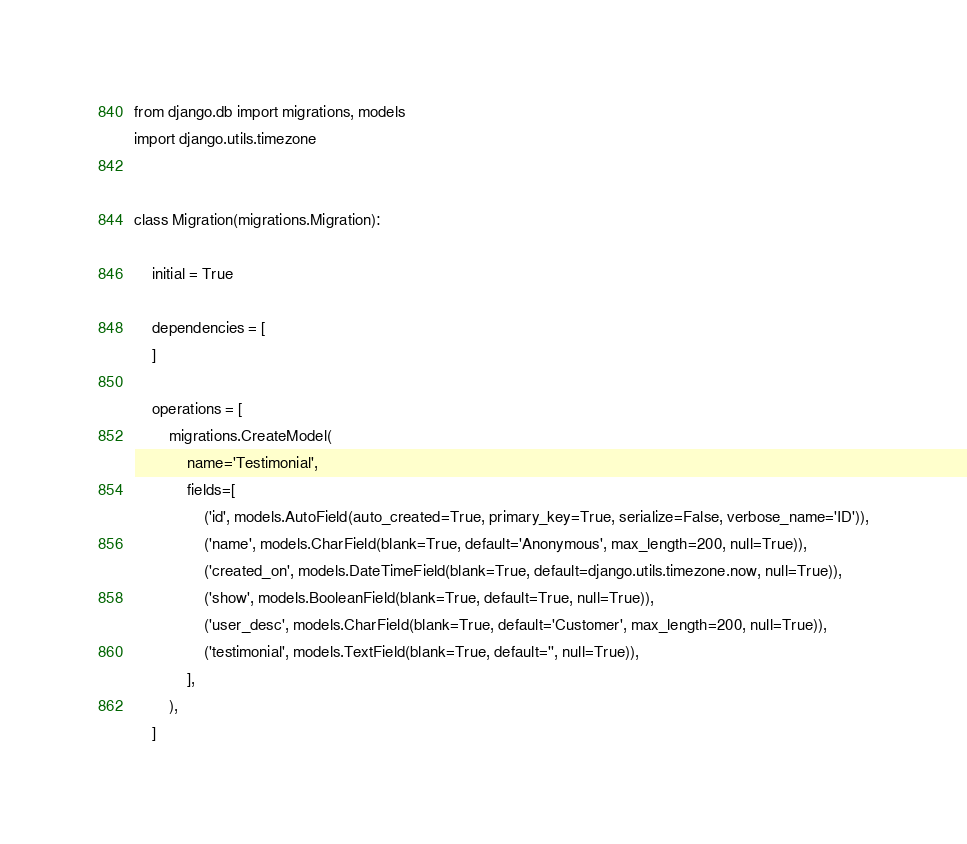Convert code to text. <code><loc_0><loc_0><loc_500><loc_500><_Python_>
from django.db import migrations, models
import django.utils.timezone


class Migration(migrations.Migration):

    initial = True

    dependencies = [
    ]

    operations = [
        migrations.CreateModel(
            name='Testimonial',
            fields=[
                ('id', models.AutoField(auto_created=True, primary_key=True, serialize=False, verbose_name='ID')),
                ('name', models.CharField(blank=True, default='Anonymous', max_length=200, null=True)),
                ('created_on', models.DateTimeField(blank=True, default=django.utils.timezone.now, null=True)),
                ('show', models.BooleanField(blank=True, default=True, null=True)),
                ('user_desc', models.CharField(blank=True, default='Customer', max_length=200, null=True)),
                ('testimonial', models.TextField(blank=True, default='', null=True)),
            ],
        ),
    ]
</code> 